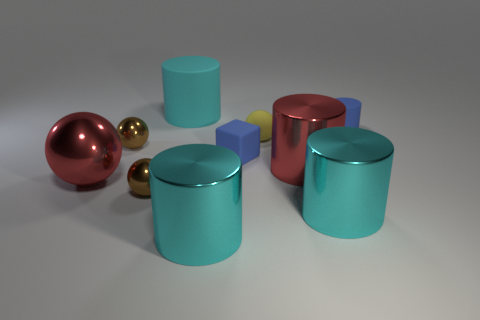Which object stands out the most to you, and why? The large red sphere stands out due to its size, vibrant color, and prominent placement in the center of the composition. It acts as a visual anchor within the image, drawing the viewer's attention as a focal point among the other objects. 